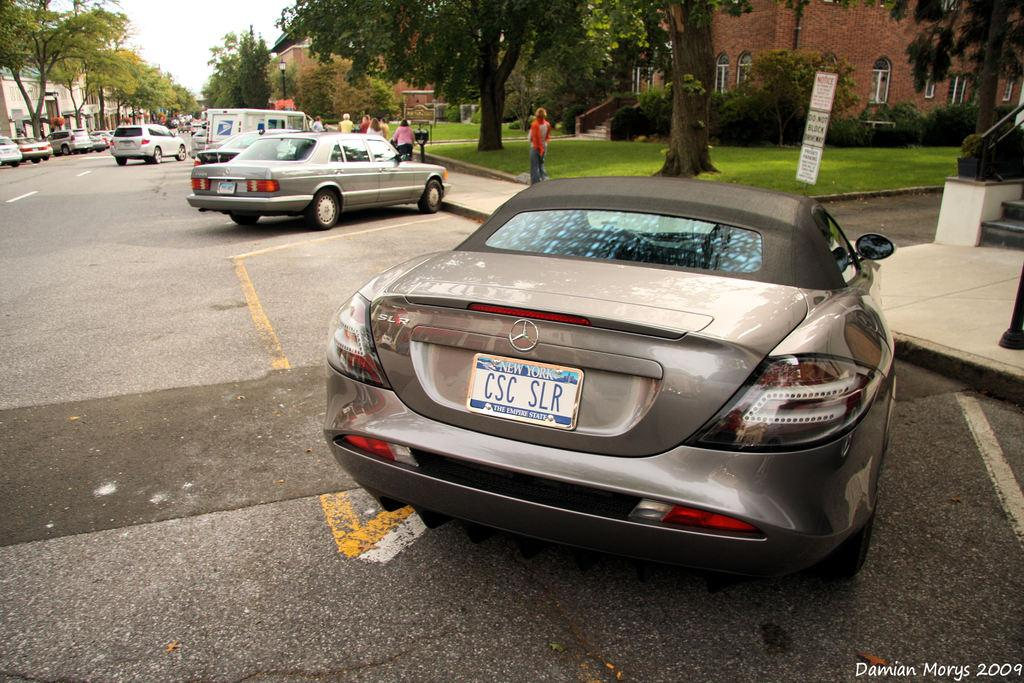What type of car is in the foreground of the image? There is a Mercedes car in the foreground of the image. What can be seen in the background of the image? The sky is visible in the background of the image. What type of sweater is the secretary wearing in the image? There is no sweater or secretary present in the image; it only a Mercedes car and the sky are visible. 